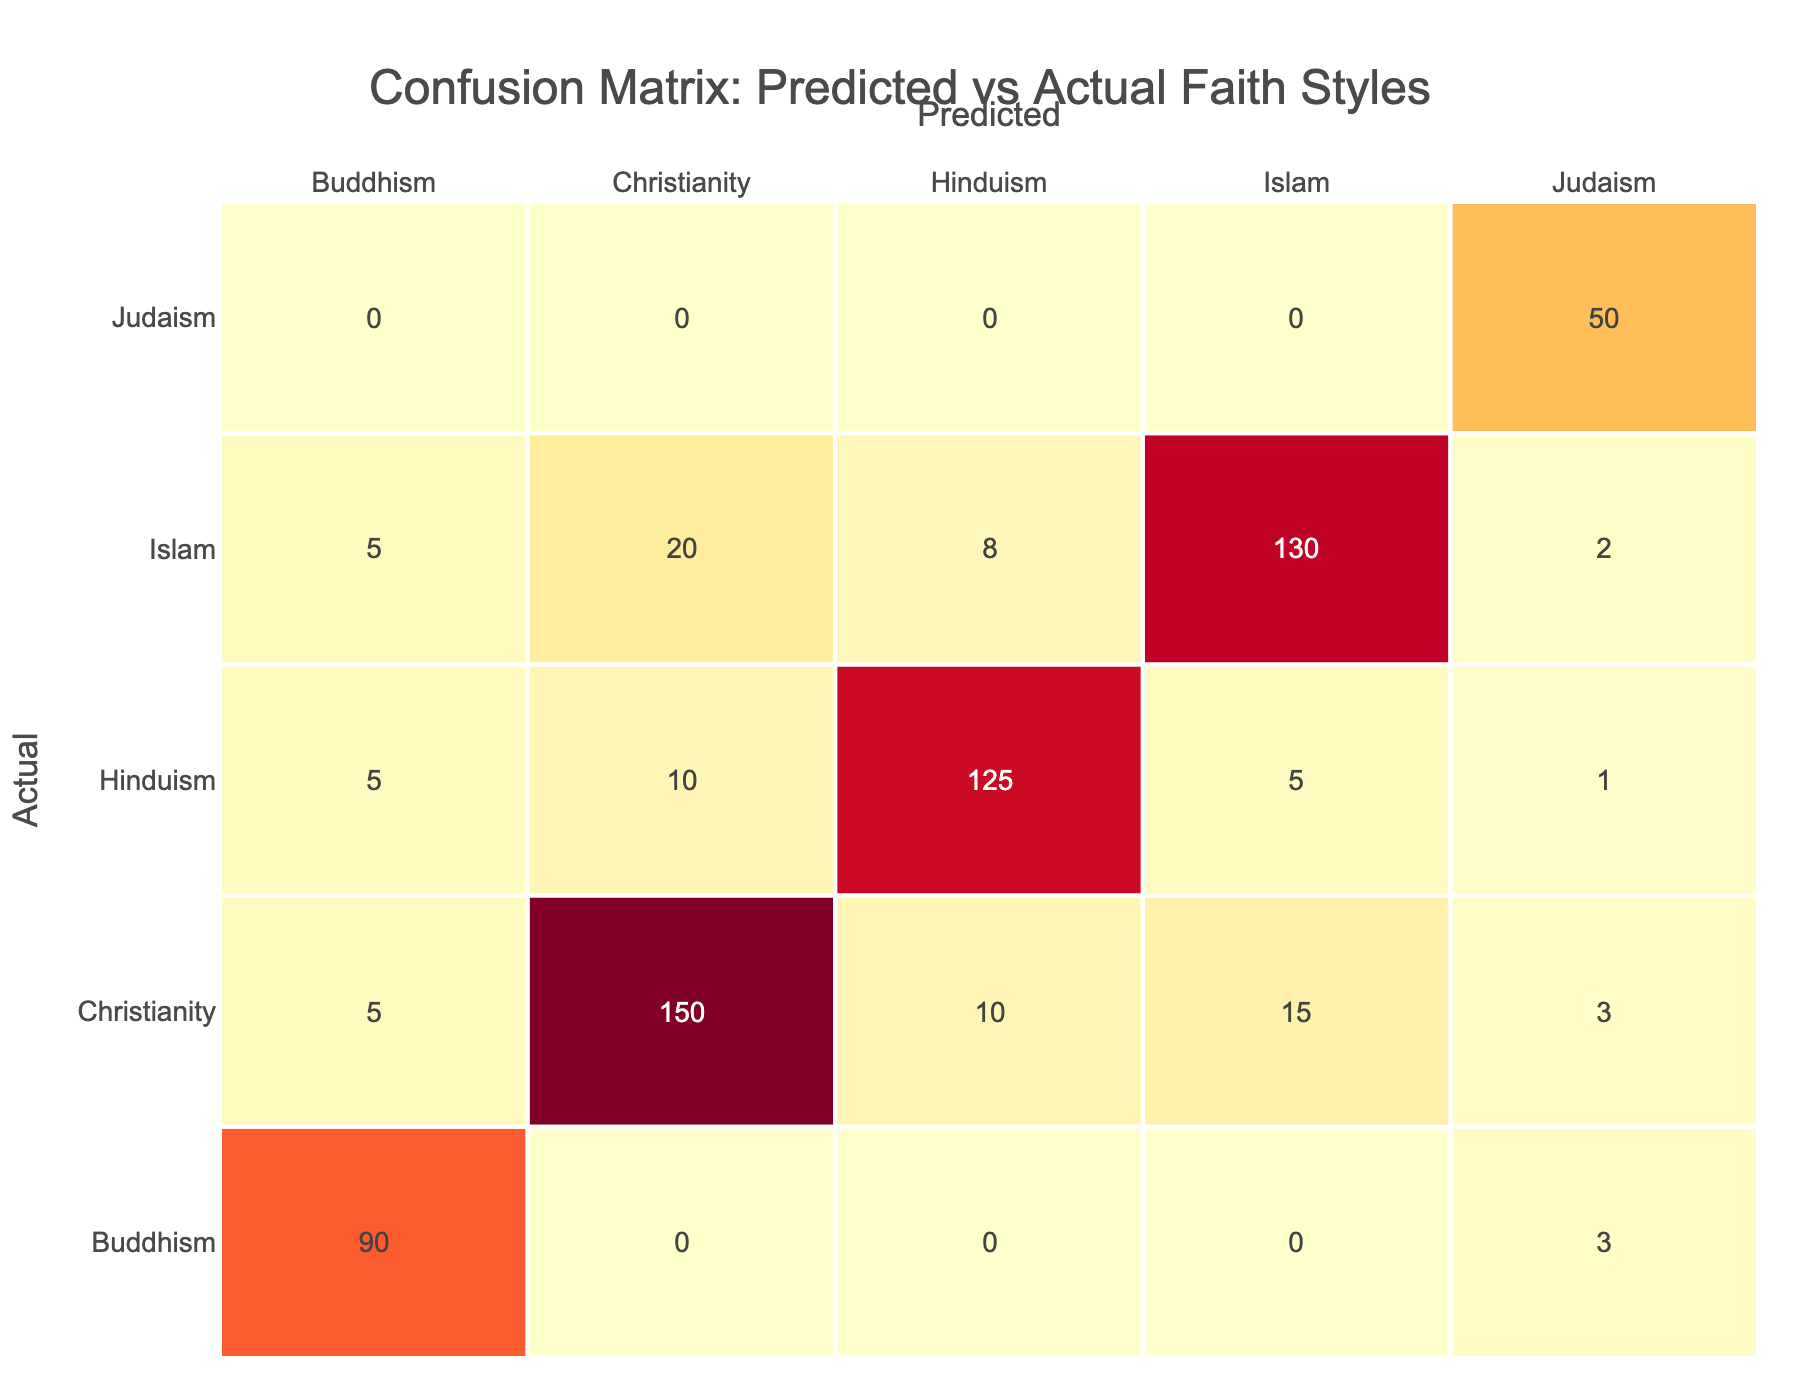What is the actual count of predicted Christianity that is accurately classified? From the table, we look at the row for Christianity under the Actual column, and find the value corresponding to Christianity in the Predicted column, which is 150.
Answer: 150 How many times was Hinduism predicted but was actually classified as Christianity? To find this, we look at the row for Christianity in the Actual column and find the value under the Hinduism Predicted column, which is 10.
Answer: 10 What is the total count of instances for Islam across both predicted and actual classifications? For Islam as Actual, we sum the counts in the corresponding row: 15 (predicted as Christianity) + 130 (predicted as Islam) + 5 (predicted as Hinduism) = 150.
Answer: 150 Are there more predictions that were accurately classified for Buddhism than for Judaism? We check the counts for Buddhism accurately classified (90) and for Judaism accurately classified (50). Since 90 is greater than 50, the answer is yes.
Answer: Yes What is the total count of misclassifications for Hinduism when predicted? We look at the row for Hinduism in the Actual column, summing the values of the Predicted column that are not Hinduism: 10 (Christianity) + 8 (Islam) = 18.
Answer: 18 How would you compare the accuracy of predictions for Christianity versus Islam? The accuracy for Christianity is 150 (predicted as Christianity) versus 130 for Islam (predicted as Islam). Thus, Christianity has a higher accuracy.
Answer: Christianity is more accurate What is the fraction of predictions correctly associated with Buddhism compared to the total predictions made for Buddhism? For Buddhism, the correct prediction is 90, while the total predictions include 5 (Christianity) + 5 (Islam) + 5 (Hinduism) + 90 (Buddhism) = 105. The fraction is 90/105, which simplifies to 6/7.
Answer: 6/7 What is the combined total of predictions made for Judaism and how many were accurate? For Judaism, the total predictions are 3 (Christianity) + 2 (Islam) + 1 (Hinduism) + 3 (Buddhism) + 50 (Judaism) = 59. The accurate predictions are 50 (Judaism).
Answer: Total: 59, Accurate: 50 Do the misclassifications across all religions show a higher volume than accurate classifications for any single religion? To find this, we calculate total misclassifications (sum of off-diagonal values) compared to any individual accuracy such as Christianity (150) or Islam (130). The total misclassifications are 20 + 10 + 15 + 5 + 10 + 8 + 5 + 5 + 3 + 2 + 1 + 3 = 73. So yes, 73 is less than 130 or 150 for any religion.
Answer: No 